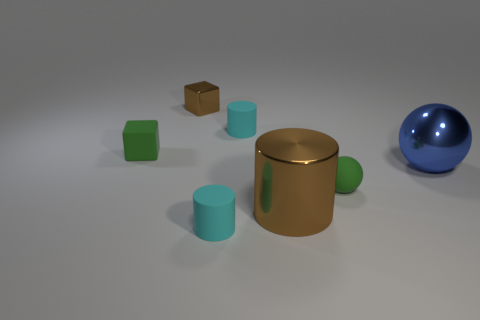Subtract all brown metallic cylinders. How many cylinders are left? 2 Subtract all cyan cubes. How many cyan cylinders are left? 2 Add 3 blue matte spheres. How many objects exist? 10 Subtract all blue spheres. How many spheres are left? 1 Subtract all balls. How many objects are left? 5 Subtract all brown cylinders. Subtract all gray cubes. How many cylinders are left? 2 Subtract all big cylinders. Subtract all small green blocks. How many objects are left? 5 Add 6 metallic balls. How many metallic balls are left? 7 Add 2 big yellow rubber cubes. How many big yellow rubber cubes exist? 2 Subtract 1 green cubes. How many objects are left? 6 